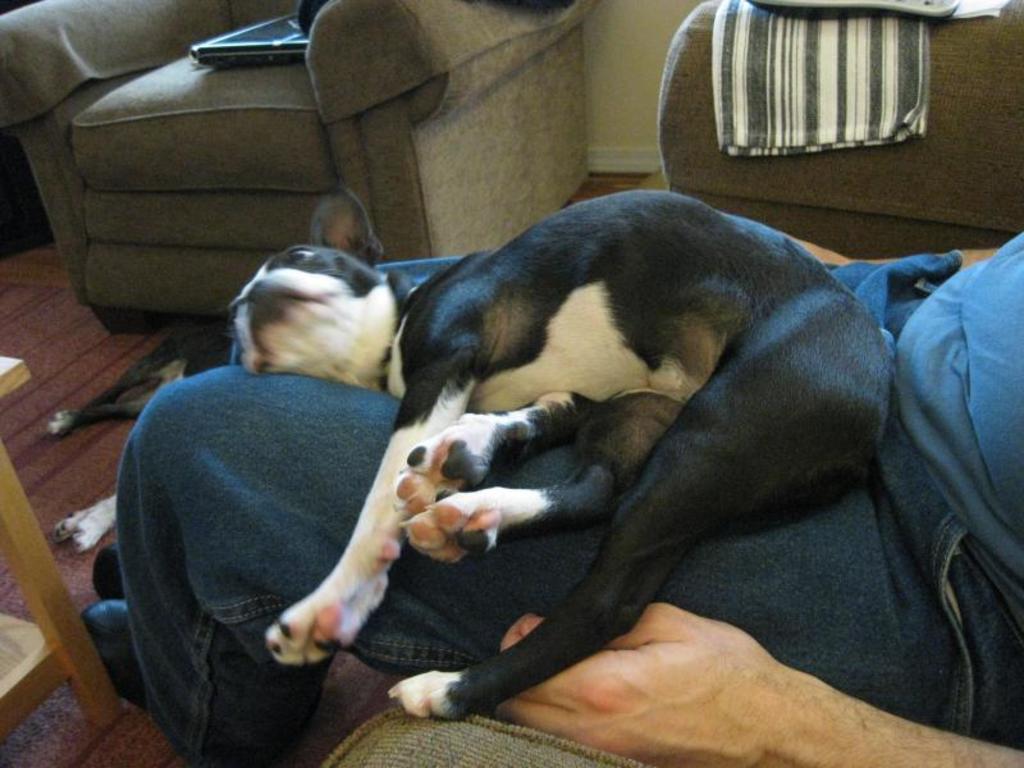Describe this image in one or two sentences. In this picture we can see a dog lying on a person who is sitting on a couch. Here we can see a sofa, laptop, and clothes. Here we can see a dog lying on the floor. 